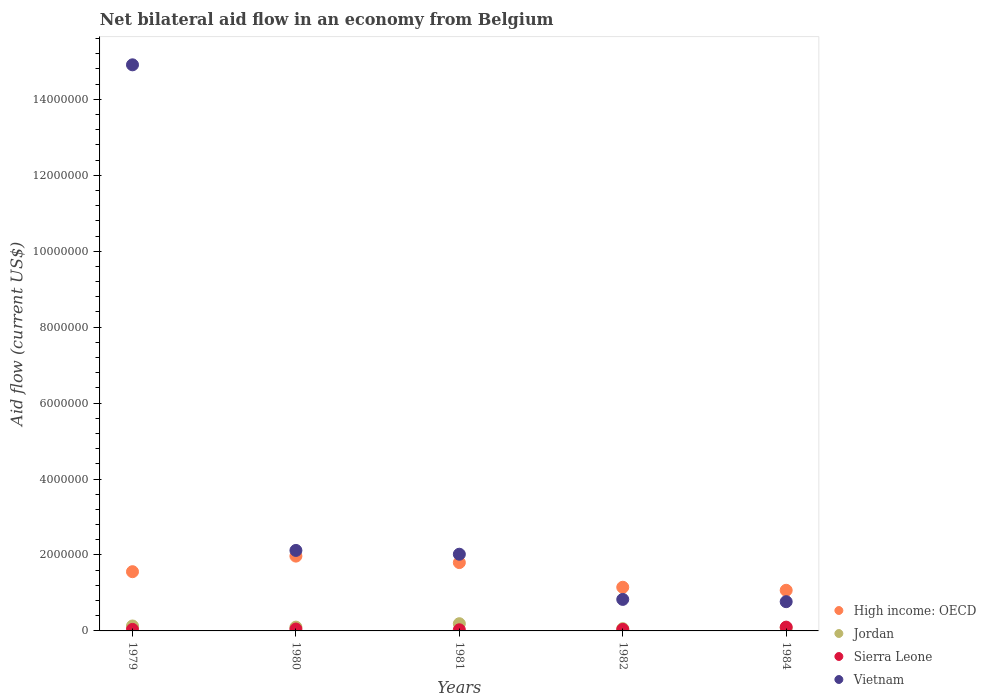What is the net bilateral aid flow in Sierra Leone in 1980?
Your answer should be compact. 5.00e+04. Across all years, what is the maximum net bilateral aid flow in High income: OECD?
Your answer should be compact. 1.97e+06. Across all years, what is the minimum net bilateral aid flow in High income: OECD?
Give a very brief answer. 1.07e+06. What is the difference between the net bilateral aid flow in High income: OECD in 1980 and that in 1981?
Ensure brevity in your answer.  1.70e+05. What is the average net bilateral aid flow in Jordan per year?
Ensure brevity in your answer.  1.12e+05. In the year 1984, what is the difference between the net bilateral aid flow in Jordan and net bilateral aid flow in Vietnam?
Provide a short and direct response. -6.90e+05. What is the ratio of the net bilateral aid flow in Sierra Leone in 1981 to that in 1984?
Offer a terse response. 0.3. Is the net bilateral aid flow in High income: OECD in 1980 less than that in 1984?
Make the answer very short. No. Is the difference between the net bilateral aid flow in Jordan in 1979 and 1980 greater than the difference between the net bilateral aid flow in Vietnam in 1979 and 1980?
Offer a terse response. No. What is the difference between the highest and the second highest net bilateral aid flow in Vietnam?
Give a very brief answer. 1.28e+07. What is the difference between the highest and the lowest net bilateral aid flow in Sierra Leone?
Make the answer very short. 7.00e+04. Does the net bilateral aid flow in Vietnam monotonically increase over the years?
Your response must be concise. No. What is the difference between two consecutive major ticks on the Y-axis?
Provide a succinct answer. 2.00e+06. Are the values on the major ticks of Y-axis written in scientific E-notation?
Your answer should be very brief. No. Where does the legend appear in the graph?
Your response must be concise. Bottom right. How are the legend labels stacked?
Make the answer very short. Vertical. What is the title of the graph?
Give a very brief answer. Net bilateral aid flow in an economy from Belgium. Does "Guam" appear as one of the legend labels in the graph?
Make the answer very short. No. What is the label or title of the X-axis?
Keep it short and to the point. Years. What is the Aid flow (current US$) of High income: OECD in 1979?
Ensure brevity in your answer.  1.56e+06. What is the Aid flow (current US$) of Vietnam in 1979?
Your response must be concise. 1.49e+07. What is the Aid flow (current US$) in High income: OECD in 1980?
Your answer should be very brief. 1.97e+06. What is the Aid flow (current US$) in Sierra Leone in 1980?
Keep it short and to the point. 5.00e+04. What is the Aid flow (current US$) in Vietnam in 1980?
Your response must be concise. 2.12e+06. What is the Aid flow (current US$) in High income: OECD in 1981?
Give a very brief answer. 1.80e+06. What is the Aid flow (current US$) in Jordan in 1981?
Offer a very short reply. 1.90e+05. What is the Aid flow (current US$) of Sierra Leone in 1981?
Provide a short and direct response. 3.00e+04. What is the Aid flow (current US$) in Vietnam in 1981?
Your answer should be compact. 2.02e+06. What is the Aid flow (current US$) in High income: OECD in 1982?
Make the answer very short. 1.15e+06. What is the Aid flow (current US$) of Vietnam in 1982?
Your response must be concise. 8.30e+05. What is the Aid flow (current US$) of High income: OECD in 1984?
Keep it short and to the point. 1.07e+06. What is the Aid flow (current US$) in Jordan in 1984?
Your answer should be compact. 8.00e+04. What is the Aid flow (current US$) of Vietnam in 1984?
Give a very brief answer. 7.70e+05. Across all years, what is the maximum Aid flow (current US$) of High income: OECD?
Your response must be concise. 1.97e+06. Across all years, what is the maximum Aid flow (current US$) of Jordan?
Your answer should be compact. 1.90e+05. Across all years, what is the maximum Aid flow (current US$) in Vietnam?
Give a very brief answer. 1.49e+07. Across all years, what is the minimum Aid flow (current US$) in High income: OECD?
Make the answer very short. 1.07e+06. Across all years, what is the minimum Aid flow (current US$) in Sierra Leone?
Give a very brief answer. 3.00e+04. Across all years, what is the minimum Aid flow (current US$) of Vietnam?
Make the answer very short. 7.70e+05. What is the total Aid flow (current US$) of High income: OECD in the graph?
Your answer should be compact. 7.55e+06. What is the total Aid flow (current US$) of Jordan in the graph?
Your answer should be compact. 5.60e+05. What is the total Aid flow (current US$) in Vietnam in the graph?
Offer a terse response. 2.06e+07. What is the difference between the Aid flow (current US$) in High income: OECD in 1979 and that in 1980?
Your response must be concise. -4.10e+05. What is the difference between the Aid flow (current US$) in Jordan in 1979 and that in 1980?
Make the answer very short. 3.00e+04. What is the difference between the Aid flow (current US$) in Sierra Leone in 1979 and that in 1980?
Make the answer very short. -10000. What is the difference between the Aid flow (current US$) in Vietnam in 1979 and that in 1980?
Offer a terse response. 1.28e+07. What is the difference between the Aid flow (current US$) of Vietnam in 1979 and that in 1981?
Your response must be concise. 1.29e+07. What is the difference between the Aid flow (current US$) in Jordan in 1979 and that in 1982?
Give a very brief answer. 7.00e+04. What is the difference between the Aid flow (current US$) in Sierra Leone in 1979 and that in 1982?
Ensure brevity in your answer.  0. What is the difference between the Aid flow (current US$) of Vietnam in 1979 and that in 1982?
Your answer should be compact. 1.41e+07. What is the difference between the Aid flow (current US$) in Sierra Leone in 1979 and that in 1984?
Offer a very short reply. -6.00e+04. What is the difference between the Aid flow (current US$) of Vietnam in 1979 and that in 1984?
Provide a short and direct response. 1.41e+07. What is the difference between the Aid flow (current US$) of Jordan in 1980 and that in 1981?
Provide a succinct answer. -9.00e+04. What is the difference between the Aid flow (current US$) of Sierra Leone in 1980 and that in 1981?
Provide a succinct answer. 2.00e+04. What is the difference between the Aid flow (current US$) of High income: OECD in 1980 and that in 1982?
Your answer should be compact. 8.20e+05. What is the difference between the Aid flow (current US$) in Sierra Leone in 1980 and that in 1982?
Give a very brief answer. 10000. What is the difference between the Aid flow (current US$) in Vietnam in 1980 and that in 1982?
Your response must be concise. 1.29e+06. What is the difference between the Aid flow (current US$) in High income: OECD in 1980 and that in 1984?
Provide a succinct answer. 9.00e+05. What is the difference between the Aid flow (current US$) of Vietnam in 1980 and that in 1984?
Provide a succinct answer. 1.35e+06. What is the difference between the Aid flow (current US$) of High income: OECD in 1981 and that in 1982?
Your response must be concise. 6.50e+05. What is the difference between the Aid flow (current US$) of Jordan in 1981 and that in 1982?
Offer a terse response. 1.30e+05. What is the difference between the Aid flow (current US$) in Sierra Leone in 1981 and that in 1982?
Ensure brevity in your answer.  -10000. What is the difference between the Aid flow (current US$) in Vietnam in 1981 and that in 1982?
Make the answer very short. 1.19e+06. What is the difference between the Aid flow (current US$) in High income: OECD in 1981 and that in 1984?
Ensure brevity in your answer.  7.30e+05. What is the difference between the Aid flow (current US$) of Jordan in 1981 and that in 1984?
Your response must be concise. 1.10e+05. What is the difference between the Aid flow (current US$) of Sierra Leone in 1981 and that in 1984?
Ensure brevity in your answer.  -7.00e+04. What is the difference between the Aid flow (current US$) in Vietnam in 1981 and that in 1984?
Your answer should be very brief. 1.25e+06. What is the difference between the Aid flow (current US$) of Vietnam in 1982 and that in 1984?
Ensure brevity in your answer.  6.00e+04. What is the difference between the Aid flow (current US$) of High income: OECD in 1979 and the Aid flow (current US$) of Jordan in 1980?
Ensure brevity in your answer.  1.46e+06. What is the difference between the Aid flow (current US$) in High income: OECD in 1979 and the Aid flow (current US$) in Sierra Leone in 1980?
Offer a terse response. 1.51e+06. What is the difference between the Aid flow (current US$) in High income: OECD in 1979 and the Aid flow (current US$) in Vietnam in 1980?
Provide a short and direct response. -5.60e+05. What is the difference between the Aid flow (current US$) of Jordan in 1979 and the Aid flow (current US$) of Vietnam in 1980?
Your answer should be very brief. -1.99e+06. What is the difference between the Aid flow (current US$) in Sierra Leone in 1979 and the Aid flow (current US$) in Vietnam in 1980?
Offer a terse response. -2.08e+06. What is the difference between the Aid flow (current US$) of High income: OECD in 1979 and the Aid flow (current US$) of Jordan in 1981?
Your answer should be compact. 1.37e+06. What is the difference between the Aid flow (current US$) in High income: OECD in 1979 and the Aid flow (current US$) in Sierra Leone in 1981?
Your answer should be very brief. 1.53e+06. What is the difference between the Aid flow (current US$) of High income: OECD in 1979 and the Aid flow (current US$) of Vietnam in 1981?
Keep it short and to the point. -4.60e+05. What is the difference between the Aid flow (current US$) in Jordan in 1979 and the Aid flow (current US$) in Vietnam in 1981?
Ensure brevity in your answer.  -1.89e+06. What is the difference between the Aid flow (current US$) in Sierra Leone in 1979 and the Aid flow (current US$) in Vietnam in 1981?
Give a very brief answer. -1.98e+06. What is the difference between the Aid flow (current US$) of High income: OECD in 1979 and the Aid flow (current US$) of Jordan in 1982?
Your answer should be very brief. 1.50e+06. What is the difference between the Aid flow (current US$) in High income: OECD in 1979 and the Aid flow (current US$) in Sierra Leone in 1982?
Offer a terse response. 1.52e+06. What is the difference between the Aid flow (current US$) of High income: OECD in 1979 and the Aid flow (current US$) of Vietnam in 1982?
Offer a very short reply. 7.30e+05. What is the difference between the Aid flow (current US$) in Jordan in 1979 and the Aid flow (current US$) in Sierra Leone in 1982?
Make the answer very short. 9.00e+04. What is the difference between the Aid flow (current US$) of Jordan in 1979 and the Aid flow (current US$) of Vietnam in 1982?
Provide a succinct answer. -7.00e+05. What is the difference between the Aid flow (current US$) in Sierra Leone in 1979 and the Aid flow (current US$) in Vietnam in 1982?
Keep it short and to the point. -7.90e+05. What is the difference between the Aid flow (current US$) in High income: OECD in 1979 and the Aid flow (current US$) in Jordan in 1984?
Make the answer very short. 1.48e+06. What is the difference between the Aid flow (current US$) of High income: OECD in 1979 and the Aid flow (current US$) of Sierra Leone in 1984?
Your answer should be compact. 1.46e+06. What is the difference between the Aid flow (current US$) in High income: OECD in 1979 and the Aid flow (current US$) in Vietnam in 1984?
Offer a very short reply. 7.90e+05. What is the difference between the Aid flow (current US$) of Jordan in 1979 and the Aid flow (current US$) of Vietnam in 1984?
Make the answer very short. -6.40e+05. What is the difference between the Aid flow (current US$) of Sierra Leone in 1979 and the Aid flow (current US$) of Vietnam in 1984?
Give a very brief answer. -7.30e+05. What is the difference between the Aid flow (current US$) in High income: OECD in 1980 and the Aid flow (current US$) in Jordan in 1981?
Keep it short and to the point. 1.78e+06. What is the difference between the Aid flow (current US$) of High income: OECD in 1980 and the Aid flow (current US$) of Sierra Leone in 1981?
Provide a succinct answer. 1.94e+06. What is the difference between the Aid flow (current US$) of Jordan in 1980 and the Aid flow (current US$) of Vietnam in 1981?
Your response must be concise. -1.92e+06. What is the difference between the Aid flow (current US$) of Sierra Leone in 1980 and the Aid flow (current US$) of Vietnam in 1981?
Offer a very short reply. -1.97e+06. What is the difference between the Aid flow (current US$) of High income: OECD in 1980 and the Aid flow (current US$) of Jordan in 1982?
Offer a terse response. 1.91e+06. What is the difference between the Aid flow (current US$) of High income: OECD in 1980 and the Aid flow (current US$) of Sierra Leone in 1982?
Your answer should be very brief. 1.93e+06. What is the difference between the Aid flow (current US$) in High income: OECD in 1980 and the Aid flow (current US$) in Vietnam in 1982?
Offer a terse response. 1.14e+06. What is the difference between the Aid flow (current US$) of Jordan in 1980 and the Aid flow (current US$) of Sierra Leone in 1982?
Provide a succinct answer. 6.00e+04. What is the difference between the Aid flow (current US$) in Jordan in 1980 and the Aid flow (current US$) in Vietnam in 1982?
Provide a succinct answer. -7.30e+05. What is the difference between the Aid flow (current US$) in Sierra Leone in 1980 and the Aid flow (current US$) in Vietnam in 1982?
Provide a short and direct response. -7.80e+05. What is the difference between the Aid flow (current US$) in High income: OECD in 1980 and the Aid flow (current US$) in Jordan in 1984?
Your answer should be compact. 1.89e+06. What is the difference between the Aid flow (current US$) of High income: OECD in 1980 and the Aid flow (current US$) of Sierra Leone in 1984?
Your answer should be very brief. 1.87e+06. What is the difference between the Aid flow (current US$) of High income: OECD in 1980 and the Aid flow (current US$) of Vietnam in 1984?
Ensure brevity in your answer.  1.20e+06. What is the difference between the Aid flow (current US$) in Jordan in 1980 and the Aid flow (current US$) in Vietnam in 1984?
Ensure brevity in your answer.  -6.70e+05. What is the difference between the Aid flow (current US$) of Sierra Leone in 1980 and the Aid flow (current US$) of Vietnam in 1984?
Provide a short and direct response. -7.20e+05. What is the difference between the Aid flow (current US$) in High income: OECD in 1981 and the Aid flow (current US$) in Jordan in 1982?
Your answer should be compact. 1.74e+06. What is the difference between the Aid flow (current US$) of High income: OECD in 1981 and the Aid flow (current US$) of Sierra Leone in 1982?
Provide a short and direct response. 1.76e+06. What is the difference between the Aid flow (current US$) of High income: OECD in 1981 and the Aid flow (current US$) of Vietnam in 1982?
Provide a succinct answer. 9.70e+05. What is the difference between the Aid flow (current US$) of Jordan in 1981 and the Aid flow (current US$) of Sierra Leone in 1982?
Provide a short and direct response. 1.50e+05. What is the difference between the Aid flow (current US$) in Jordan in 1981 and the Aid flow (current US$) in Vietnam in 1982?
Your response must be concise. -6.40e+05. What is the difference between the Aid flow (current US$) in Sierra Leone in 1981 and the Aid flow (current US$) in Vietnam in 1982?
Make the answer very short. -8.00e+05. What is the difference between the Aid flow (current US$) of High income: OECD in 1981 and the Aid flow (current US$) of Jordan in 1984?
Make the answer very short. 1.72e+06. What is the difference between the Aid flow (current US$) in High income: OECD in 1981 and the Aid flow (current US$) in Sierra Leone in 1984?
Your answer should be very brief. 1.70e+06. What is the difference between the Aid flow (current US$) of High income: OECD in 1981 and the Aid flow (current US$) of Vietnam in 1984?
Provide a succinct answer. 1.03e+06. What is the difference between the Aid flow (current US$) in Jordan in 1981 and the Aid flow (current US$) in Vietnam in 1984?
Your response must be concise. -5.80e+05. What is the difference between the Aid flow (current US$) in Sierra Leone in 1981 and the Aid flow (current US$) in Vietnam in 1984?
Keep it short and to the point. -7.40e+05. What is the difference between the Aid flow (current US$) of High income: OECD in 1982 and the Aid flow (current US$) of Jordan in 1984?
Give a very brief answer. 1.07e+06. What is the difference between the Aid flow (current US$) in High income: OECD in 1982 and the Aid flow (current US$) in Sierra Leone in 1984?
Your response must be concise. 1.05e+06. What is the difference between the Aid flow (current US$) of Jordan in 1982 and the Aid flow (current US$) of Sierra Leone in 1984?
Provide a short and direct response. -4.00e+04. What is the difference between the Aid flow (current US$) in Jordan in 1982 and the Aid flow (current US$) in Vietnam in 1984?
Make the answer very short. -7.10e+05. What is the difference between the Aid flow (current US$) in Sierra Leone in 1982 and the Aid flow (current US$) in Vietnam in 1984?
Offer a terse response. -7.30e+05. What is the average Aid flow (current US$) of High income: OECD per year?
Your answer should be very brief. 1.51e+06. What is the average Aid flow (current US$) in Jordan per year?
Your answer should be compact. 1.12e+05. What is the average Aid flow (current US$) of Sierra Leone per year?
Offer a very short reply. 5.20e+04. What is the average Aid flow (current US$) in Vietnam per year?
Ensure brevity in your answer.  4.13e+06. In the year 1979, what is the difference between the Aid flow (current US$) of High income: OECD and Aid flow (current US$) of Jordan?
Your answer should be very brief. 1.43e+06. In the year 1979, what is the difference between the Aid flow (current US$) of High income: OECD and Aid flow (current US$) of Sierra Leone?
Provide a succinct answer. 1.52e+06. In the year 1979, what is the difference between the Aid flow (current US$) of High income: OECD and Aid flow (current US$) of Vietnam?
Your answer should be compact. -1.34e+07. In the year 1979, what is the difference between the Aid flow (current US$) in Jordan and Aid flow (current US$) in Sierra Leone?
Ensure brevity in your answer.  9.00e+04. In the year 1979, what is the difference between the Aid flow (current US$) in Jordan and Aid flow (current US$) in Vietnam?
Make the answer very short. -1.48e+07. In the year 1979, what is the difference between the Aid flow (current US$) in Sierra Leone and Aid flow (current US$) in Vietnam?
Your answer should be compact. -1.49e+07. In the year 1980, what is the difference between the Aid flow (current US$) of High income: OECD and Aid flow (current US$) of Jordan?
Your response must be concise. 1.87e+06. In the year 1980, what is the difference between the Aid flow (current US$) of High income: OECD and Aid flow (current US$) of Sierra Leone?
Offer a very short reply. 1.92e+06. In the year 1980, what is the difference between the Aid flow (current US$) in High income: OECD and Aid flow (current US$) in Vietnam?
Offer a terse response. -1.50e+05. In the year 1980, what is the difference between the Aid flow (current US$) of Jordan and Aid flow (current US$) of Vietnam?
Provide a succinct answer. -2.02e+06. In the year 1980, what is the difference between the Aid flow (current US$) of Sierra Leone and Aid flow (current US$) of Vietnam?
Make the answer very short. -2.07e+06. In the year 1981, what is the difference between the Aid flow (current US$) of High income: OECD and Aid flow (current US$) of Jordan?
Give a very brief answer. 1.61e+06. In the year 1981, what is the difference between the Aid flow (current US$) in High income: OECD and Aid flow (current US$) in Sierra Leone?
Keep it short and to the point. 1.77e+06. In the year 1981, what is the difference between the Aid flow (current US$) of Jordan and Aid flow (current US$) of Vietnam?
Make the answer very short. -1.83e+06. In the year 1981, what is the difference between the Aid flow (current US$) in Sierra Leone and Aid flow (current US$) in Vietnam?
Give a very brief answer. -1.99e+06. In the year 1982, what is the difference between the Aid flow (current US$) in High income: OECD and Aid flow (current US$) in Jordan?
Give a very brief answer. 1.09e+06. In the year 1982, what is the difference between the Aid flow (current US$) of High income: OECD and Aid flow (current US$) of Sierra Leone?
Your answer should be compact. 1.11e+06. In the year 1982, what is the difference between the Aid flow (current US$) in Jordan and Aid flow (current US$) in Sierra Leone?
Provide a succinct answer. 2.00e+04. In the year 1982, what is the difference between the Aid flow (current US$) in Jordan and Aid flow (current US$) in Vietnam?
Your response must be concise. -7.70e+05. In the year 1982, what is the difference between the Aid flow (current US$) in Sierra Leone and Aid flow (current US$) in Vietnam?
Give a very brief answer. -7.90e+05. In the year 1984, what is the difference between the Aid flow (current US$) in High income: OECD and Aid flow (current US$) in Jordan?
Your response must be concise. 9.90e+05. In the year 1984, what is the difference between the Aid flow (current US$) in High income: OECD and Aid flow (current US$) in Sierra Leone?
Offer a very short reply. 9.70e+05. In the year 1984, what is the difference between the Aid flow (current US$) of Jordan and Aid flow (current US$) of Vietnam?
Ensure brevity in your answer.  -6.90e+05. In the year 1984, what is the difference between the Aid flow (current US$) in Sierra Leone and Aid flow (current US$) in Vietnam?
Give a very brief answer. -6.70e+05. What is the ratio of the Aid flow (current US$) of High income: OECD in 1979 to that in 1980?
Ensure brevity in your answer.  0.79. What is the ratio of the Aid flow (current US$) of Jordan in 1979 to that in 1980?
Your response must be concise. 1.3. What is the ratio of the Aid flow (current US$) in Vietnam in 1979 to that in 1980?
Provide a short and direct response. 7.03. What is the ratio of the Aid flow (current US$) of High income: OECD in 1979 to that in 1981?
Give a very brief answer. 0.87. What is the ratio of the Aid flow (current US$) in Jordan in 1979 to that in 1981?
Give a very brief answer. 0.68. What is the ratio of the Aid flow (current US$) of Vietnam in 1979 to that in 1981?
Offer a terse response. 7.38. What is the ratio of the Aid flow (current US$) in High income: OECD in 1979 to that in 1982?
Your answer should be very brief. 1.36. What is the ratio of the Aid flow (current US$) of Jordan in 1979 to that in 1982?
Offer a very short reply. 2.17. What is the ratio of the Aid flow (current US$) of Sierra Leone in 1979 to that in 1982?
Provide a succinct answer. 1. What is the ratio of the Aid flow (current US$) in Vietnam in 1979 to that in 1982?
Provide a succinct answer. 17.96. What is the ratio of the Aid flow (current US$) in High income: OECD in 1979 to that in 1984?
Your answer should be very brief. 1.46. What is the ratio of the Aid flow (current US$) of Jordan in 1979 to that in 1984?
Provide a short and direct response. 1.62. What is the ratio of the Aid flow (current US$) of Vietnam in 1979 to that in 1984?
Provide a succinct answer. 19.36. What is the ratio of the Aid flow (current US$) in High income: OECD in 1980 to that in 1981?
Keep it short and to the point. 1.09. What is the ratio of the Aid flow (current US$) in Jordan in 1980 to that in 1981?
Ensure brevity in your answer.  0.53. What is the ratio of the Aid flow (current US$) in Vietnam in 1980 to that in 1981?
Give a very brief answer. 1.05. What is the ratio of the Aid flow (current US$) in High income: OECD in 1980 to that in 1982?
Offer a terse response. 1.71. What is the ratio of the Aid flow (current US$) in Jordan in 1980 to that in 1982?
Ensure brevity in your answer.  1.67. What is the ratio of the Aid flow (current US$) of Sierra Leone in 1980 to that in 1982?
Ensure brevity in your answer.  1.25. What is the ratio of the Aid flow (current US$) in Vietnam in 1980 to that in 1982?
Make the answer very short. 2.55. What is the ratio of the Aid flow (current US$) in High income: OECD in 1980 to that in 1984?
Ensure brevity in your answer.  1.84. What is the ratio of the Aid flow (current US$) in Vietnam in 1980 to that in 1984?
Offer a terse response. 2.75. What is the ratio of the Aid flow (current US$) in High income: OECD in 1981 to that in 1982?
Your answer should be compact. 1.57. What is the ratio of the Aid flow (current US$) of Jordan in 1981 to that in 1982?
Offer a very short reply. 3.17. What is the ratio of the Aid flow (current US$) of Sierra Leone in 1981 to that in 1982?
Your response must be concise. 0.75. What is the ratio of the Aid flow (current US$) in Vietnam in 1981 to that in 1982?
Provide a succinct answer. 2.43. What is the ratio of the Aid flow (current US$) in High income: OECD in 1981 to that in 1984?
Keep it short and to the point. 1.68. What is the ratio of the Aid flow (current US$) in Jordan in 1981 to that in 1984?
Make the answer very short. 2.38. What is the ratio of the Aid flow (current US$) of Sierra Leone in 1981 to that in 1984?
Provide a short and direct response. 0.3. What is the ratio of the Aid flow (current US$) of Vietnam in 1981 to that in 1984?
Provide a succinct answer. 2.62. What is the ratio of the Aid flow (current US$) in High income: OECD in 1982 to that in 1984?
Offer a terse response. 1.07. What is the ratio of the Aid flow (current US$) of Sierra Leone in 1982 to that in 1984?
Your answer should be very brief. 0.4. What is the ratio of the Aid flow (current US$) of Vietnam in 1982 to that in 1984?
Offer a very short reply. 1.08. What is the difference between the highest and the second highest Aid flow (current US$) of Sierra Leone?
Offer a very short reply. 5.00e+04. What is the difference between the highest and the second highest Aid flow (current US$) of Vietnam?
Your answer should be compact. 1.28e+07. What is the difference between the highest and the lowest Aid flow (current US$) of Sierra Leone?
Offer a very short reply. 7.00e+04. What is the difference between the highest and the lowest Aid flow (current US$) of Vietnam?
Your answer should be very brief. 1.41e+07. 